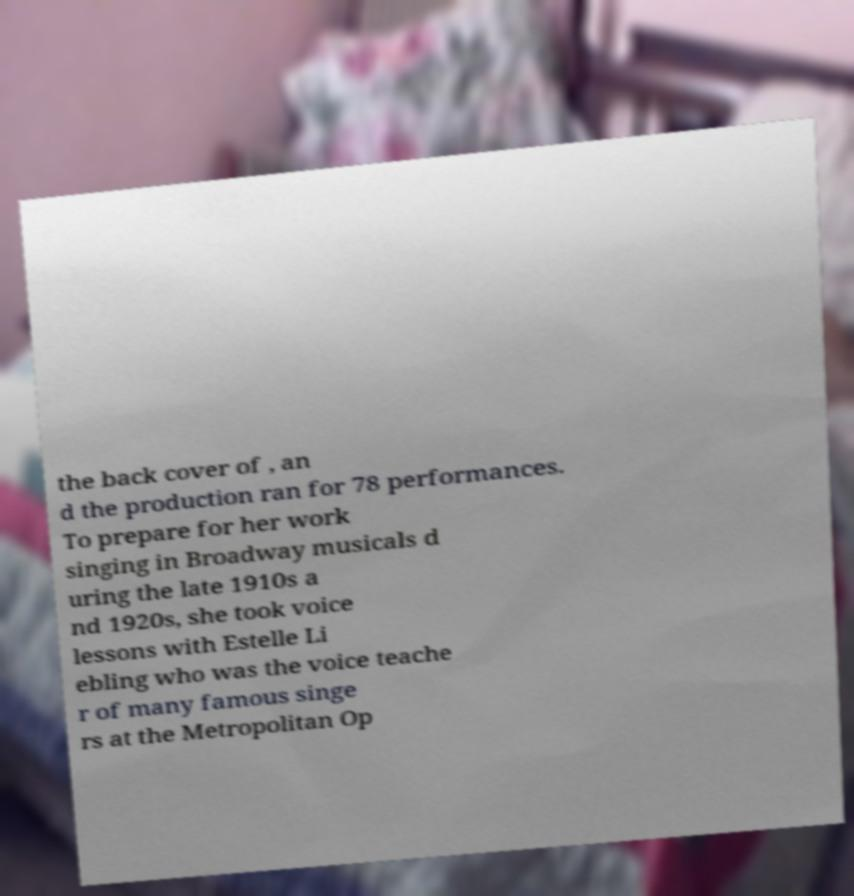For documentation purposes, I need the text within this image transcribed. Could you provide that? the back cover of , an d the production ran for 78 performances. To prepare for her work singing in Broadway musicals d uring the late 1910s a nd 1920s, she took voice lessons with Estelle Li ebling who was the voice teache r of many famous singe rs at the Metropolitan Op 